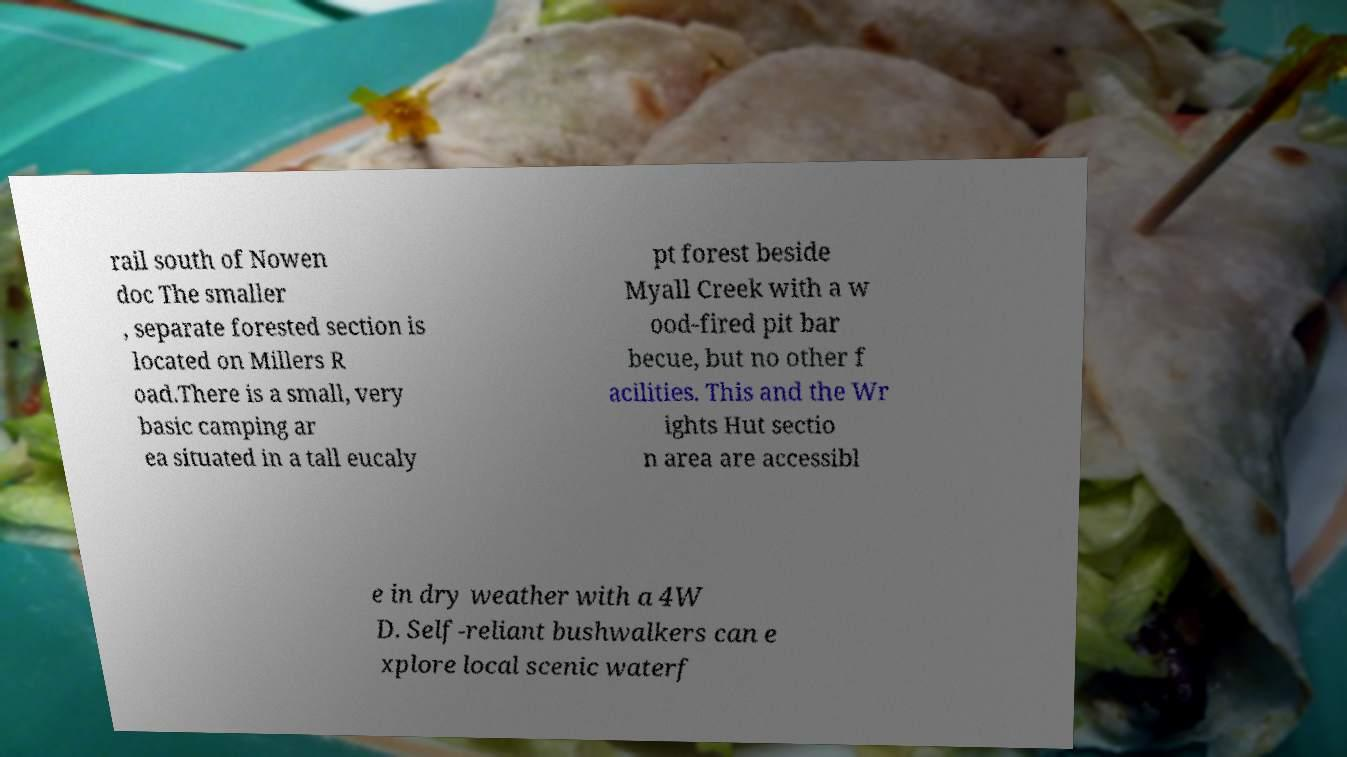Could you extract and type out the text from this image? rail south of Nowen doc The smaller , separate forested section is located on Millers R oad.There is a small, very basic camping ar ea situated in a tall eucaly pt forest beside Myall Creek with a w ood-fired pit bar becue, but no other f acilities. This and the Wr ights Hut sectio n area are accessibl e in dry weather with a 4W D. Self-reliant bushwalkers can e xplore local scenic waterf 